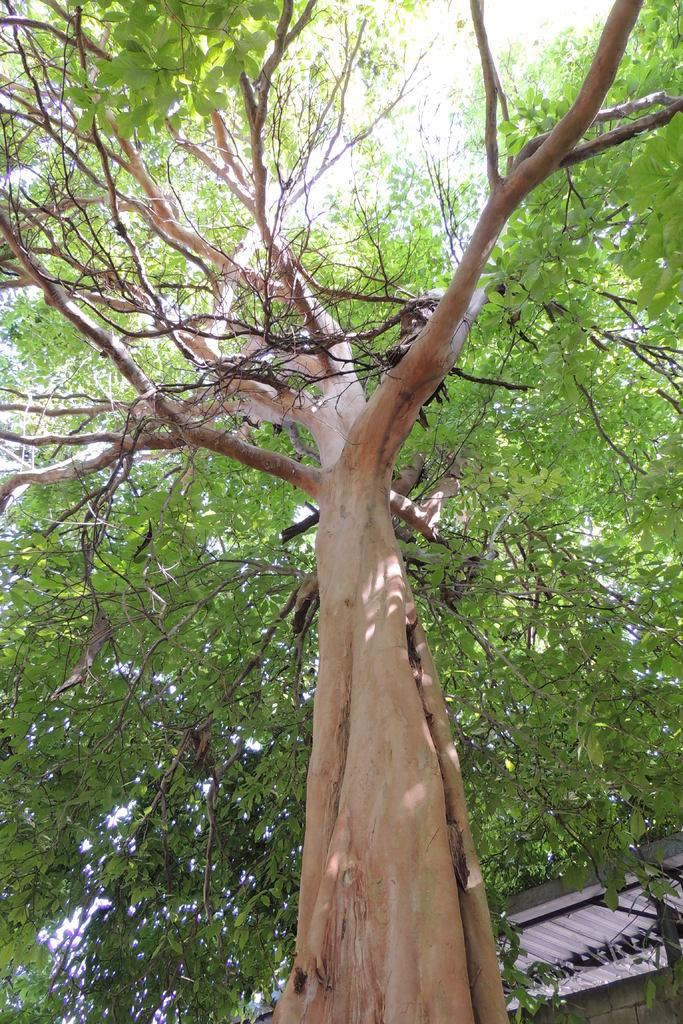What type of plant can be seen in the image? There is a tree in the image. What structure is located on the right side of the image? There is a shed on the right side of the image. What is visible at the top of the image? The sky is visible at the top of the image. What type of liquid is being squeezed out of the tree in the image? There is no liquid being squeezed out of the tree in the image; it is a stationary plant. Can you see any toothpaste on the tree in the image? There is no toothpaste present in the image. 